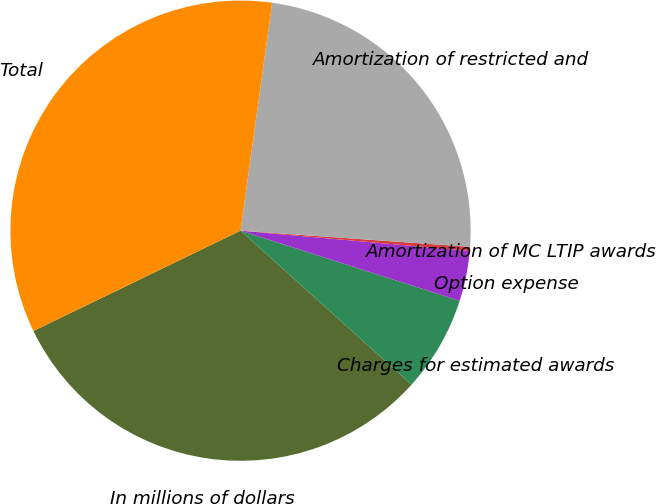Convert chart. <chart><loc_0><loc_0><loc_500><loc_500><pie_chart><fcel>In millions of dollars<fcel>Charges for estimated awards<fcel>Option expense<fcel>Amortization of MC LTIP awards<fcel>Amortization of restricted and<fcel>Total<nl><fcel>31.15%<fcel>6.74%<fcel>3.52%<fcel>0.29%<fcel>23.92%<fcel>34.37%<nl></chart> 